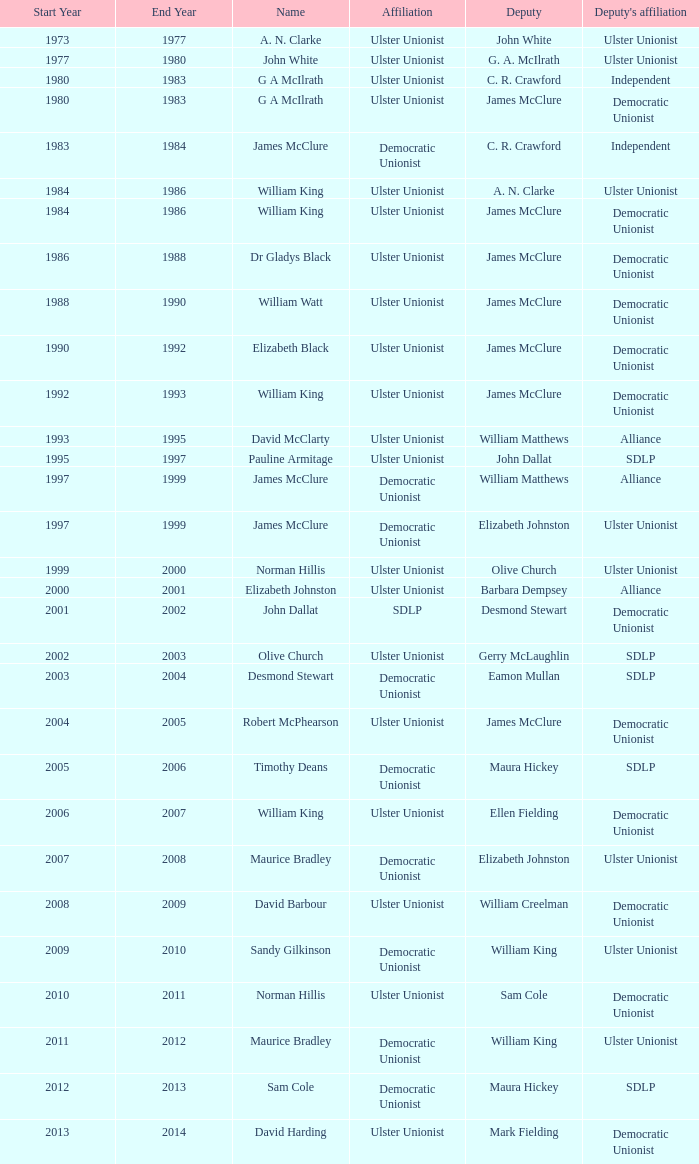What is the Name for 1997–99? James McClure, James McClure. 